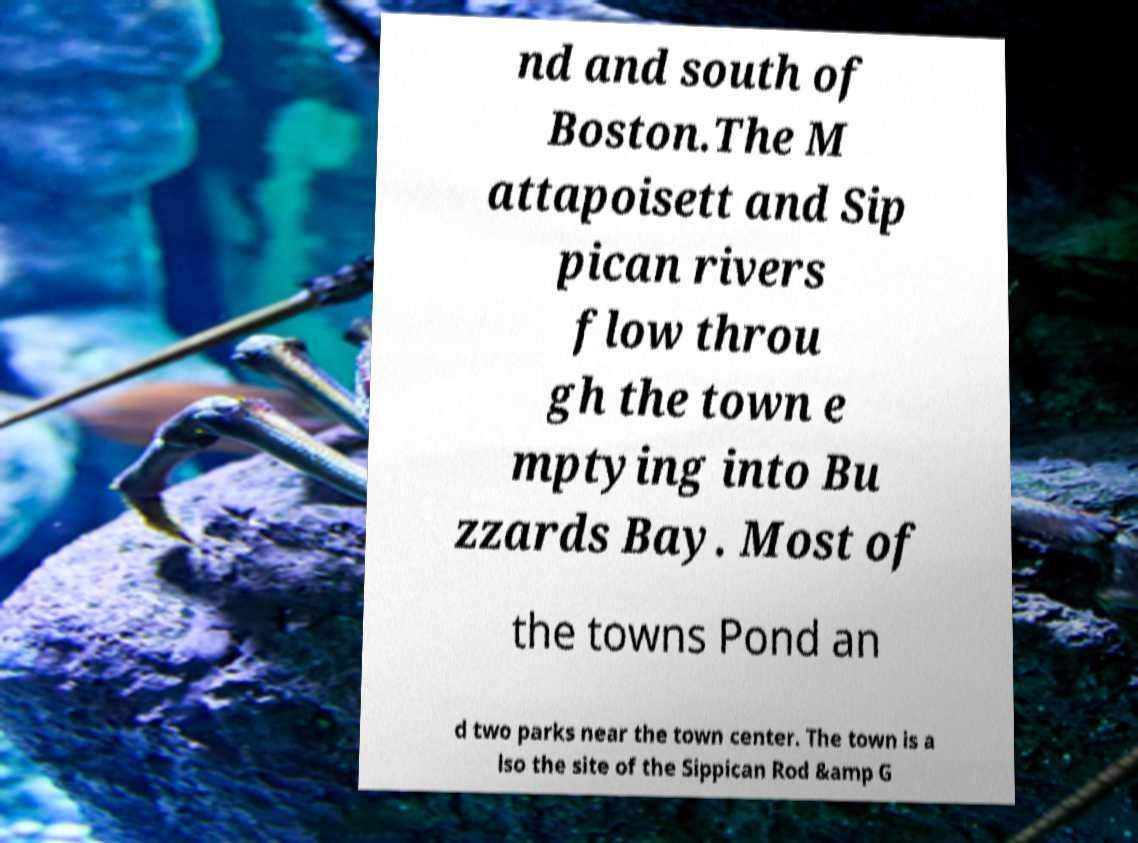Could you extract and type out the text from this image? nd and south of Boston.The M attapoisett and Sip pican rivers flow throu gh the town e mptying into Bu zzards Bay. Most of the towns Pond an d two parks near the town center. The town is a lso the site of the Sippican Rod &amp G 